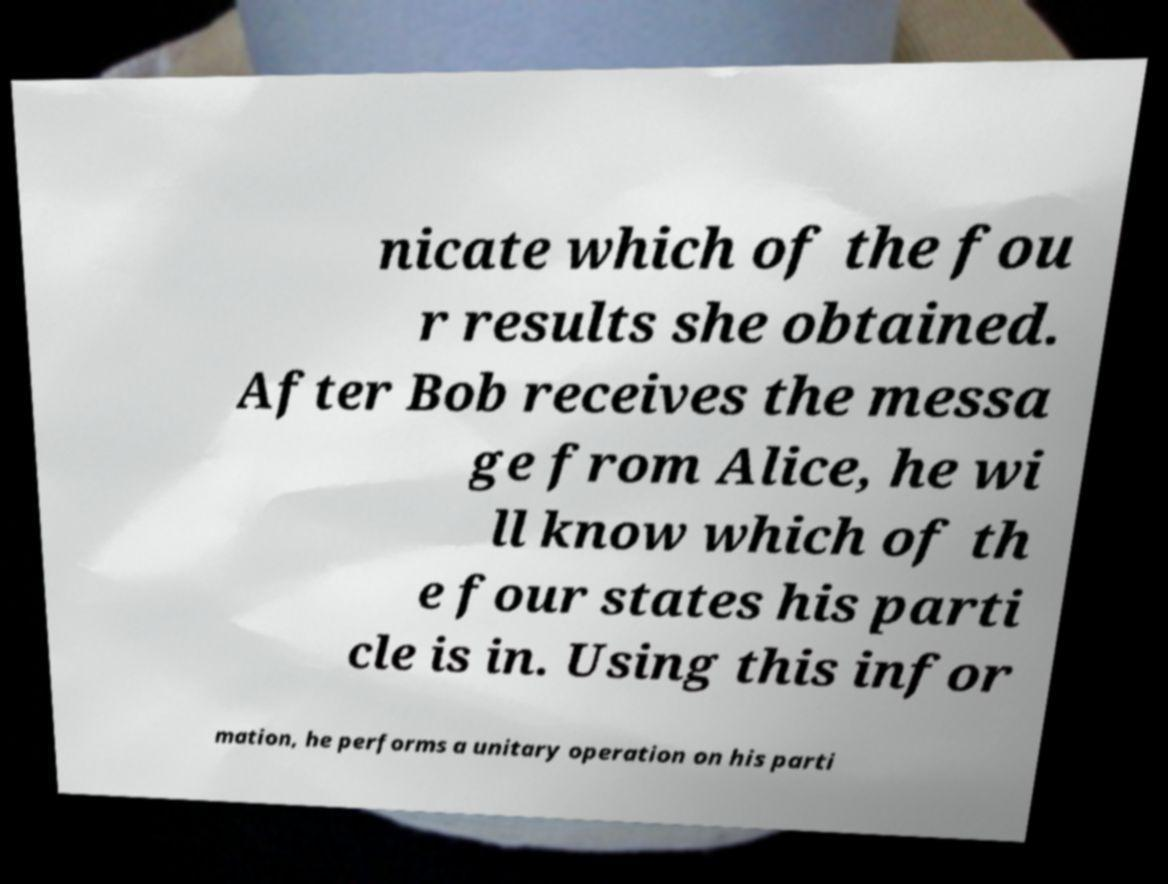There's text embedded in this image that I need extracted. Can you transcribe it verbatim? nicate which of the fou r results she obtained. After Bob receives the messa ge from Alice, he wi ll know which of th e four states his parti cle is in. Using this infor mation, he performs a unitary operation on his parti 